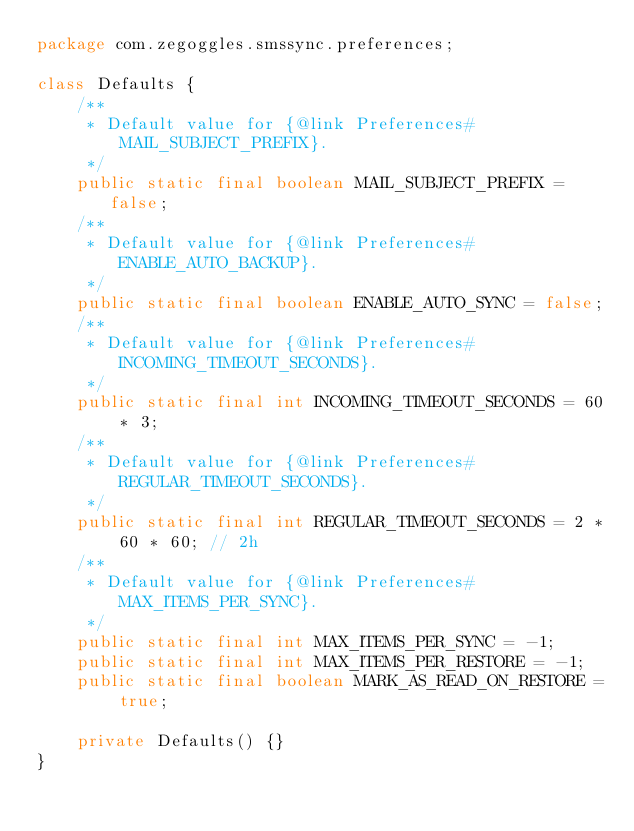<code> <loc_0><loc_0><loc_500><loc_500><_Java_>package com.zegoggles.smssync.preferences;

class Defaults {
    /**
     * Default value for {@link Preferences#MAIL_SUBJECT_PREFIX}.
     */
    public static final boolean MAIL_SUBJECT_PREFIX = false;
    /**
     * Default value for {@link Preferences#ENABLE_AUTO_BACKUP}.
     */
    public static final boolean ENABLE_AUTO_SYNC = false;
    /**
     * Default value for {@link Preferences#INCOMING_TIMEOUT_SECONDS}.
     */
    public static final int INCOMING_TIMEOUT_SECONDS = 60 * 3;
    /**
     * Default value for {@link Preferences#REGULAR_TIMEOUT_SECONDS}.
     */
    public static final int REGULAR_TIMEOUT_SECONDS = 2 * 60 * 60; // 2h
    /**
     * Default value for {@link Preferences#MAX_ITEMS_PER_SYNC}.
     */
    public static final int MAX_ITEMS_PER_SYNC = -1;
    public static final int MAX_ITEMS_PER_RESTORE = -1;
    public static final boolean MARK_AS_READ_ON_RESTORE = true;

    private Defaults() {}
}
</code> 